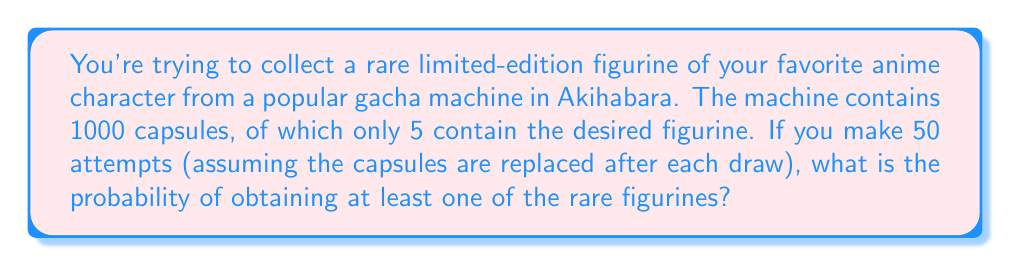Give your solution to this math problem. Let's approach this step-by-step using the binomial distribution:

1) First, we need to calculate the probability of success on a single attempt:
   $p = \frac{5}{1000} = 0.005$

2) The probability of failure on a single attempt is:
   $q = 1 - p = 0.995$

3) We want to find the probability of at least one success in 50 attempts. This is equivalent to 1 minus the probability of all failures:
   $P(\text{at least one success}) = 1 - P(\text{all failures})$

4) The probability of all failures in 50 attempts is:
   $P(\text{all failures}) = q^{50} = 0.995^{50}$

5) Therefore, the probability of at least one success is:
   $P(\text{at least one success}) = 1 - 0.995^{50}$

6) We can calculate this:
   $$\begin{align}
   P(\text{at least one success}) &= 1 - 0.995^{50} \\
   &= 1 - 0.7778 \\
   &= 0.2222
   \end{align}$$

7) Converting to a percentage:
   $0.2222 \times 100\% = 22.22\%$

Thus, the probability of obtaining at least one rare figurine in 50 attempts is approximately 22.22%.
Answer: 22.22% 